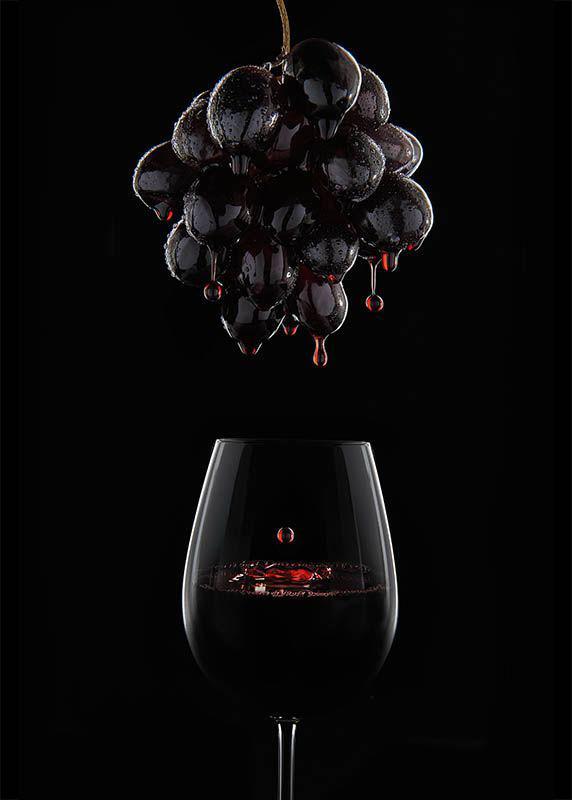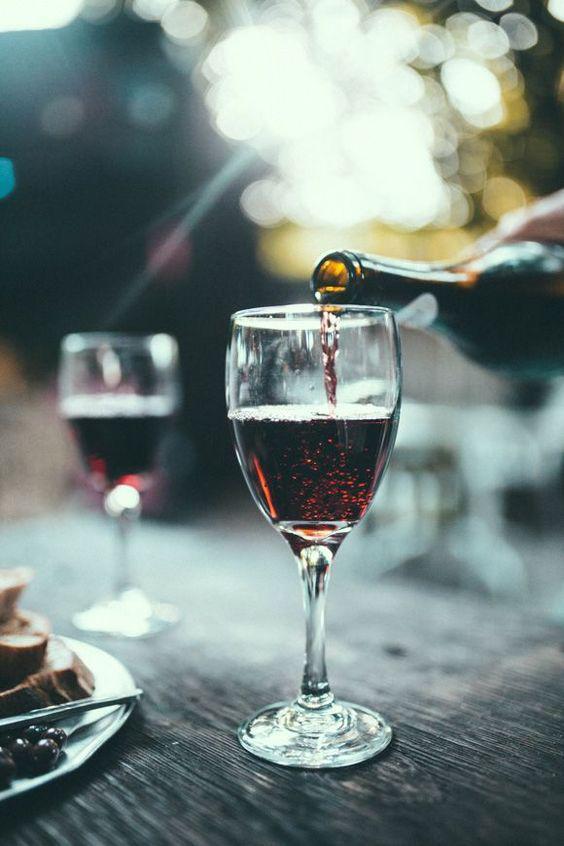The first image is the image on the left, the second image is the image on the right. Given the left and right images, does the statement "There are two wineglasses in one of the images." hold true? Answer yes or no. Yes. 